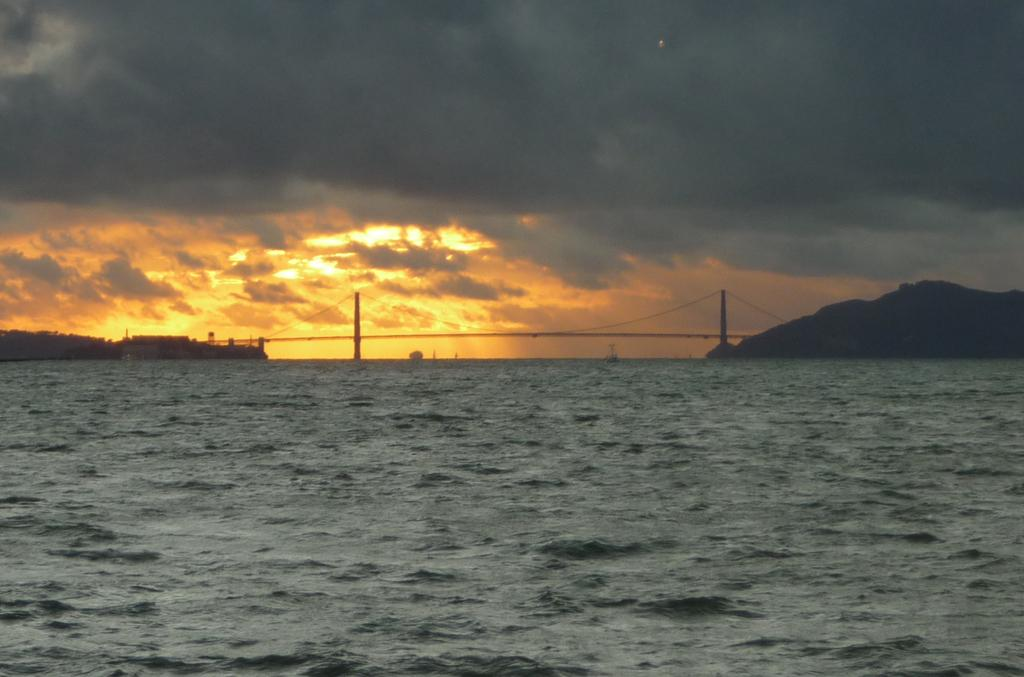What type of natural feature can be seen in the image? There is a lake in the image. What other geographical features are present in the image? There are hills in the image. Is there any man-made structure visible in the image? Yes, there is a bridge in the image. How would you describe the weather in the image? The sky is cloudy in the image. Are there any signs of human habitation or activity in the image? Yes, there are buildings in the image. What type of whip is being used in the battle depicted in the image? There is no battle or whip present in the image; it features a lake, hills, a bridge, a cloudy sky, and buildings. 